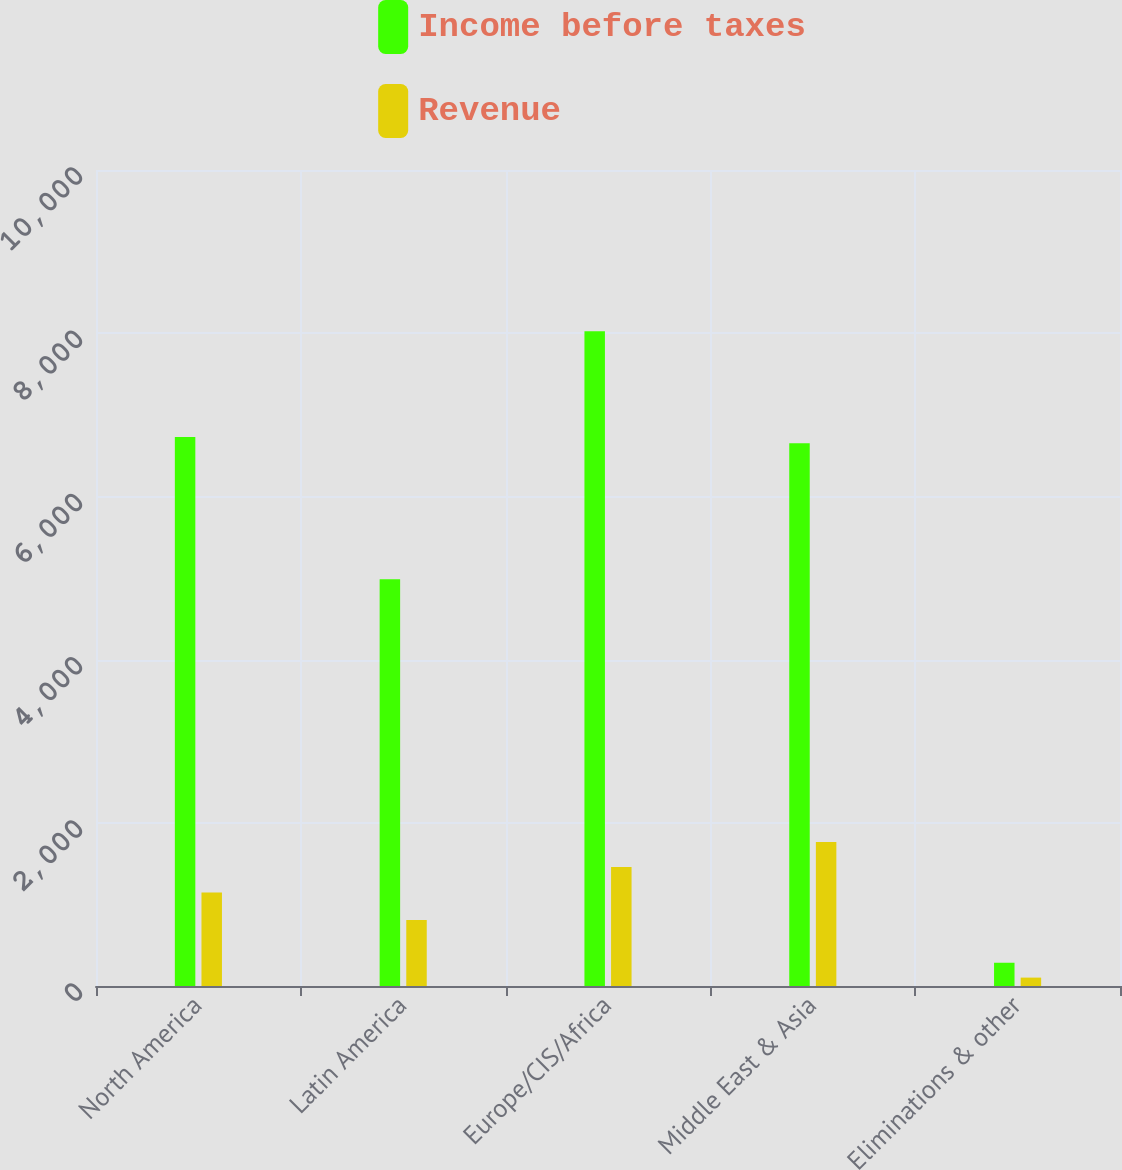<chart> <loc_0><loc_0><loc_500><loc_500><stacked_bar_chart><ecel><fcel>North America<fcel>Latin America<fcel>Europe/CIS/Africa<fcel>Middle East & Asia<fcel>Eliminations & other<nl><fcel>Income before taxes<fcel>6729<fcel>4985<fcel>8024<fcel>6650<fcel>285<nl><fcel>Revenue<fcel>1145<fcel>808<fcel>1457<fcel>1764<fcel>103<nl></chart> 